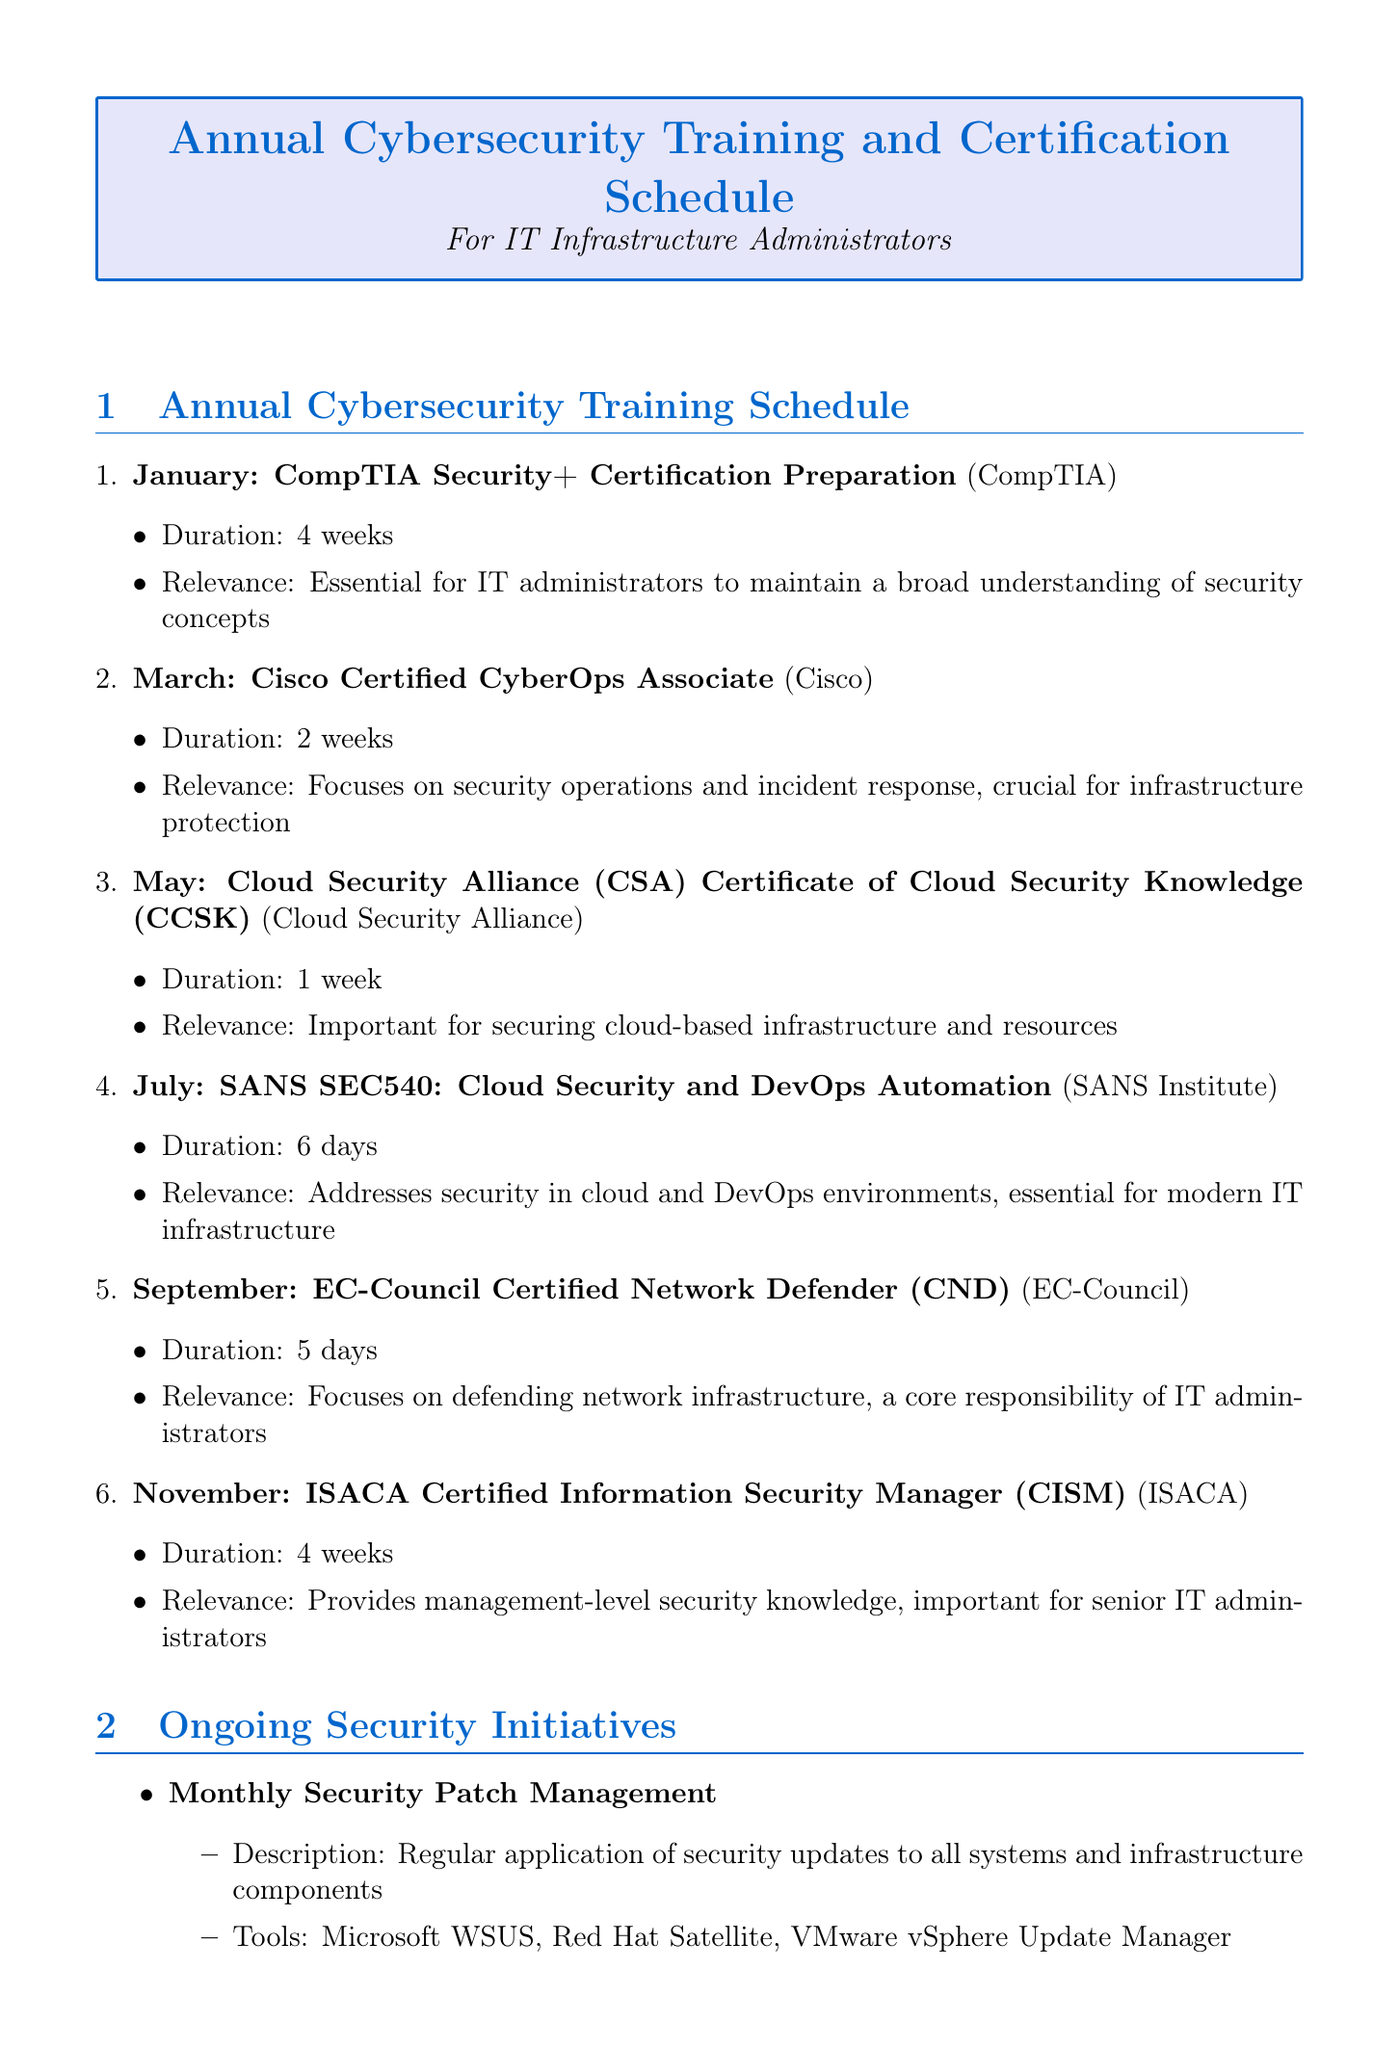What training occurs in January? The training scheduled for January is CompTIA Security+ Certification Preparation.
Answer: CompTIA Security+ Certification Preparation How long is the training in March? The duration of the training in March is indicated as 2 weeks.
Answer: 2 weeks Which organization provides the CCSK training? The document specifies that Cloud Security Alliance provides the CCSK training.
Answer: Cloud Security Alliance What is the frequency of the bi-annual penetration testing? The document states that penetration testing is conducted bi-annually, which implies twice a year.
Answer: Bi-annually What is the duration of the ISO 27001 compliance training? The document lists the duration of the ISO 27001 training as 16 hours.
Answer: 16 hours What is the primary focus of the September training? The training in September is focused on defending network infrastructure.
Answer: Defending network infrastructure Which tool training is provided by Palo Alto Networks? According to the document, Palo Alto Networks provides training for the Next-generation firewall.
Answer: Next-generation firewall How often are quarterly vulnerability assessments conducted? The document indicates that these assessments are conducted quarterly, meaning four times a year.
Answer: Quarterly What is the purpose of the ransomware attack simulation? The document describes the simulation as testing response procedures during a ransomware attack.
Answer: Test response procedures 